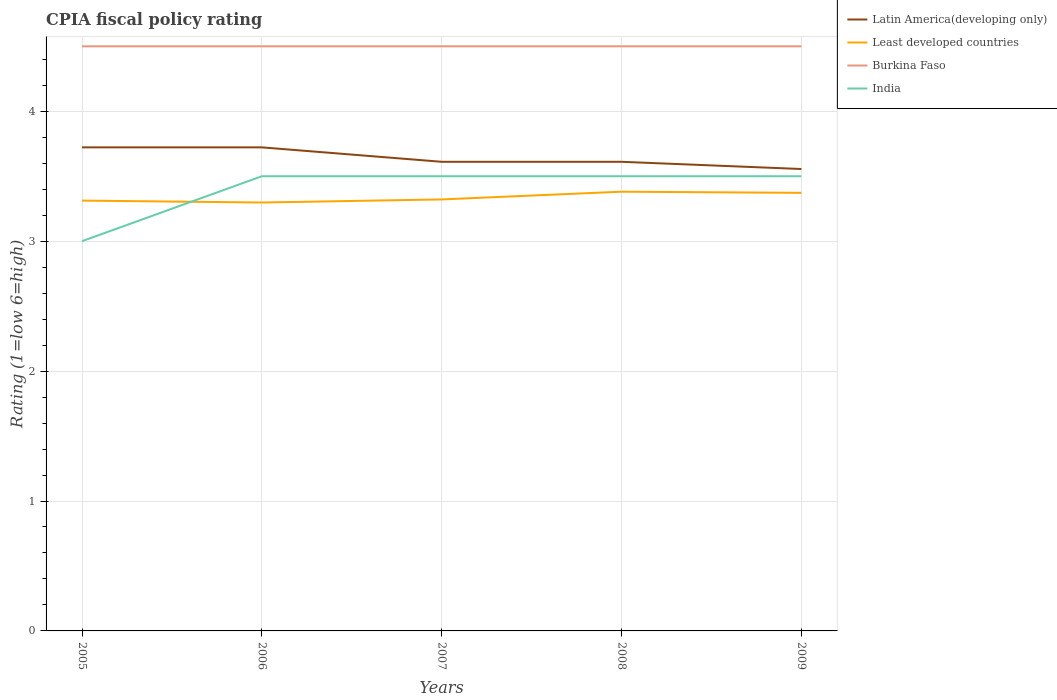Does the line corresponding to Burkina Faso intersect with the line corresponding to India?
Offer a very short reply. No. Across all years, what is the maximum CPIA rating in Latin America(developing only)?
Your answer should be very brief. 3.56. What is the total CPIA rating in India in the graph?
Provide a short and direct response. -0.5. What is the difference between the highest and the second highest CPIA rating in Burkina Faso?
Keep it short and to the point. 0. Is the CPIA rating in Latin America(developing only) strictly greater than the CPIA rating in Burkina Faso over the years?
Your response must be concise. Yes. What is the difference between two consecutive major ticks on the Y-axis?
Give a very brief answer. 1. Does the graph contain any zero values?
Keep it short and to the point. No. How many legend labels are there?
Your answer should be compact. 4. What is the title of the graph?
Offer a terse response. CPIA fiscal policy rating. Does "New Zealand" appear as one of the legend labels in the graph?
Provide a short and direct response. No. What is the label or title of the X-axis?
Give a very brief answer. Years. What is the Rating (1=low 6=high) in Latin America(developing only) in 2005?
Your answer should be compact. 3.72. What is the Rating (1=low 6=high) of Least developed countries in 2005?
Offer a very short reply. 3.31. What is the Rating (1=low 6=high) in India in 2005?
Provide a short and direct response. 3. What is the Rating (1=low 6=high) in Latin America(developing only) in 2006?
Provide a short and direct response. 3.72. What is the Rating (1=low 6=high) of Least developed countries in 2006?
Make the answer very short. 3.3. What is the Rating (1=low 6=high) in India in 2006?
Your answer should be very brief. 3.5. What is the Rating (1=low 6=high) in Latin America(developing only) in 2007?
Your answer should be very brief. 3.61. What is the Rating (1=low 6=high) in Least developed countries in 2007?
Make the answer very short. 3.32. What is the Rating (1=low 6=high) of Burkina Faso in 2007?
Provide a short and direct response. 4.5. What is the Rating (1=low 6=high) of India in 2007?
Make the answer very short. 3.5. What is the Rating (1=low 6=high) of Latin America(developing only) in 2008?
Offer a very short reply. 3.61. What is the Rating (1=low 6=high) of Least developed countries in 2008?
Make the answer very short. 3.38. What is the Rating (1=low 6=high) in Latin America(developing only) in 2009?
Keep it short and to the point. 3.56. What is the Rating (1=low 6=high) in Least developed countries in 2009?
Your answer should be compact. 3.37. What is the Rating (1=low 6=high) in India in 2009?
Your response must be concise. 3.5. Across all years, what is the maximum Rating (1=low 6=high) in Latin America(developing only)?
Your response must be concise. 3.72. Across all years, what is the maximum Rating (1=low 6=high) in Least developed countries?
Keep it short and to the point. 3.38. Across all years, what is the maximum Rating (1=low 6=high) in India?
Provide a short and direct response. 3.5. Across all years, what is the minimum Rating (1=low 6=high) in Latin America(developing only)?
Keep it short and to the point. 3.56. Across all years, what is the minimum Rating (1=low 6=high) in Least developed countries?
Give a very brief answer. 3.3. What is the total Rating (1=low 6=high) of Latin America(developing only) in the graph?
Offer a terse response. 18.22. What is the total Rating (1=low 6=high) of Least developed countries in the graph?
Provide a short and direct response. 16.68. What is the total Rating (1=low 6=high) of India in the graph?
Offer a terse response. 17. What is the difference between the Rating (1=low 6=high) of Least developed countries in 2005 and that in 2006?
Your answer should be compact. 0.01. What is the difference between the Rating (1=low 6=high) of Burkina Faso in 2005 and that in 2006?
Keep it short and to the point. 0. What is the difference between the Rating (1=low 6=high) in India in 2005 and that in 2006?
Offer a terse response. -0.5. What is the difference between the Rating (1=low 6=high) in Least developed countries in 2005 and that in 2007?
Make the answer very short. -0.01. What is the difference between the Rating (1=low 6=high) of Burkina Faso in 2005 and that in 2007?
Your answer should be compact. 0. What is the difference between the Rating (1=low 6=high) in India in 2005 and that in 2007?
Your answer should be compact. -0.5. What is the difference between the Rating (1=low 6=high) of Latin America(developing only) in 2005 and that in 2008?
Your answer should be very brief. 0.11. What is the difference between the Rating (1=low 6=high) in Least developed countries in 2005 and that in 2008?
Offer a terse response. -0.07. What is the difference between the Rating (1=low 6=high) of Burkina Faso in 2005 and that in 2008?
Your answer should be compact. 0. What is the difference between the Rating (1=low 6=high) in Latin America(developing only) in 2005 and that in 2009?
Your answer should be compact. 0.17. What is the difference between the Rating (1=low 6=high) of Least developed countries in 2005 and that in 2009?
Offer a very short reply. -0.06. What is the difference between the Rating (1=low 6=high) in Burkina Faso in 2005 and that in 2009?
Offer a very short reply. 0. What is the difference between the Rating (1=low 6=high) of India in 2005 and that in 2009?
Your answer should be compact. -0.5. What is the difference between the Rating (1=low 6=high) of Latin America(developing only) in 2006 and that in 2007?
Give a very brief answer. 0.11. What is the difference between the Rating (1=low 6=high) in Least developed countries in 2006 and that in 2007?
Your response must be concise. -0.02. What is the difference between the Rating (1=low 6=high) of India in 2006 and that in 2007?
Offer a terse response. 0. What is the difference between the Rating (1=low 6=high) in Latin America(developing only) in 2006 and that in 2008?
Keep it short and to the point. 0.11. What is the difference between the Rating (1=low 6=high) of Least developed countries in 2006 and that in 2008?
Ensure brevity in your answer.  -0.08. What is the difference between the Rating (1=low 6=high) of Latin America(developing only) in 2006 and that in 2009?
Your answer should be compact. 0.17. What is the difference between the Rating (1=low 6=high) of Least developed countries in 2006 and that in 2009?
Give a very brief answer. -0.07. What is the difference between the Rating (1=low 6=high) of Burkina Faso in 2006 and that in 2009?
Keep it short and to the point. 0. What is the difference between the Rating (1=low 6=high) in India in 2006 and that in 2009?
Provide a short and direct response. 0. What is the difference between the Rating (1=low 6=high) of Latin America(developing only) in 2007 and that in 2008?
Ensure brevity in your answer.  0. What is the difference between the Rating (1=low 6=high) in Least developed countries in 2007 and that in 2008?
Your response must be concise. -0.06. What is the difference between the Rating (1=low 6=high) in India in 2007 and that in 2008?
Offer a very short reply. 0. What is the difference between the Rating (1=low 6=high) in Latin America(developing only) in 2007 and that in 2009?
Give a very brief answer. 0.06. What is the difference between the Rating (1=low 6=high) in Least developed countries in 2007 and that in 2009?
Your answer should be compact. -0.05. What is the difference between the Rating (1=low 6=high) in Burkina Faso in 2007 and that in 2009?
Keep it short and to the point. 0. What is the difference between the Rating (1=low 6=high) in India in 2007 and that in 2009?
Your answer should be compact. 0. What is the difference between the Rating (1=low 6=high) in Latin America(developing only) in 2008 and that in 2009?
Provide a short and direct response. 0.06. What is the difference between the Rating (1=low 6=high) in Least developed countries in 2008 and that in 2009?
Give a very brief answer. 0.01. What is the difference between the Rating (1=low 6=high) of Burkina Faso in 2008 and that in 2009?
Offer a terse response. 0. What is the difference between the Rating (1=low 6=high) of Latin America(developing only) in 2005 and the Rating (1=low 6=high) of Least developed countries in 2006?
Your answer should be very brief. 0.42. What is the difference between the Rating (1=low 6=high) in Latin America(developing only) in 2005 and the Rating (1=low 6=high) in Burkina Faso in 2006?
Your answer should be compact. -0.78. What is the difference between the Rating (1=low 6=high) in Latin America(developing only) in 2005 and the Rating (1=low 6=high) in India in 2006?
Your answer should be very brief. 0.22. What is the difference between the Rating (1=low 6=high) of Least developed countries in 2005 and the Rating (1=low 6=high) of Burkina Faso in 2006?
Give a very brief answer. -1.19. What is the difference between the Rating (1=low 6=high) in Least developed countries in 2005 and the Rating (1=low 6=high) in India in 2006?
Make the answer very short. -0.19. What is the difference between the Rating (1=low 6=high) in Latin America(developing only) in 2005 and the Rating (1=low 6=high) in Least developed countries in 2007?
Keep it short and to the point. 0.4. What is the difference between the Rating (1=low 6=high) in Latin America(developing only) in 2005 and the Rating (1=low 6=high) in Burkina Faso in 2007?
Provide a short and direct response. -0.78. What is the difference between the Rating (1=low 6=high) of Latin America(developing only) in 2005 and the Rating (1=low 6=high) of India in 2007?
Provide a succinct answer. 0.22. What is the difference between the Rating (1=low 6=high) in Least developed countries in 2005 and the Rating (1=low 6=high) in Burkina Faso in 2007?
Make the answer very short. -1.19. What is the difference between the Rating (1=low 6=high) of Least developed countries in 2005 and the Rating (1=low 6=high) of India in 2007?
Your answer should be compact. -0.19. What is the difference between the Rating (1=low 6=high) in Latin America(developing only) in 2005 and the Rating (1=low 6=high) in Least developed countries in 2008?
Offer a terse response. 0.34. What is the difference between the Rating (1=low 6=high) of Latin America(developing only) in 2005 and the Rating (1=low 6=high) of Burkina Faso in 2008?
Offer a terse response. -0.78. What is the difference between the Rating (1=low 6=high) in Latin America(developing only) in 2005 and the Rating (1=low 6=high) in India in 2008?
Your answer should be compact. 0.22. What is the difference between the Rating (1=low 6=high) of Least developed countries in 2005 and the Rating (1=low 6=high) of Burkina Faso in 2008?
Give a very brief answer. -1.19. What is the difference between the Rating (1=low 6=high) of Least developed countries in 2005 and the Rating (1=low 6=high) of India in 2008?
Provide a succinct answer. -0.19. What is the difference between the Rating (1=low 6=high) of Burkina Faso in 2005 and the Rating (1=low 6=high) of India in 2008?
Your answer should be very brief. 1. What is the difference between the Rating (1=low 6=high) of Latin America(developing only) in 2005 and the Rating (1=low 6=high) of Least developed countries in 2009?
Make the answer very short. 0.35. What is the difference between the Rating (1=low 6=high) of Latin America(developing only) in 2005 and the Rating (1=low 6=high) of Burkina Faso in 2009?
Keep it short and to the point. -0.78. What is the difference between the Rating (1=low 6=high) of Latin America(developing only) in 2005 and the Rating (1=low 6=high) of India in 2009?
Provide a succinct answer. 0.22. What is the difference between the Rating (1=low 6=high) in Least developed countries in 2005 and the Rating (1=low 6=high) in Burkina Faso in 2009?
Offer a terse response. -1.19. What is the difference between the Rating (1=low 6=high) of Least developed countries in 2005 and the Rating (1=low 6=high) of India in 2009?
Offer a terse response. -0.19. What is the difference between the Rating (1=low 6=high) in Latin America(developing only) in 2006 and the Rating (1=low 6=high) in Least developed countries in 2007?
Provide a short and direct response. 0.4. What is the difference between the Rating (1=low 6=high) of Latin America(developing only) in 2006 and the Rating (1=low 6=high) of Burkina Faso in 2007?
Offer a terse response. -0.78. What is the difference between the Rating (1=low 6=high) in Latin America(developing only) in 2006 and the Rating (1=low 6=high) in India in 2007?
Ensure brevity in your answer.  0.22. What is the difference between the Rating (1=low 6=high) of Least developed countries in 2006 and the Rating (1=low 6=high) of Burkina Faso in 2007?
Your answer should be compact. -1.2. What is the difference between the Rating (1=low 6=high) of Least developed countries in 2006 and the Rating (1=low 6=high) of India in 2007?
Make the answer very short. -0.2. What is the difference between the Rating (1=low 6=high) in Burkina Faso in 2006 and the Rating (1=low 6=high) in India in 2007?
Give a very brief answer. 1. What is the difference between the Rating (1=low 6=high) in Latin America(developing only) in 2006 and the Rating (1=low 6=high) in Least developed countries in 2008?
Your answer should be compact. 0.34. What is the difference between the Rating (1=low 6=high) in Latin America(developing only) in 2006 and the Rating (1=low 6=high) in Burkina Faso in 2008?
Provide a succinct answer. -0.78. What is the difference between the Rating (1=low 6=high) of Latin America(developing only) in 2006 and the Rating (1=low 6=high) of India in 2008?
Make the answer very short. 0.22. What is the difference between the Rating (1=low 6=high) in Least developed countries in 2006 and the Rating (1=low 6=high) in Burkina Faso in 2008?
Provide a succinct answer. -1.2. What is the difference between the Rating (1=low 6=high) of Least developed countries in 2006 and the Rating (1=low 6=high) of India in 2008?
Offer a terse response. -0.2. What is the difference between the Rating (1=low 6=high) of Latin America(developing only) in 2006 and the Rating (1=low 6=high) of Least developed countries in 2009?
Your response must be concise. 0.35. What is the difference between the Rating (1=low 6=high) of Latin America(developing only) in 2006 and the Rating (1=low 6=high) of Burkina Faso in 2009?
Offer a very short reply. -0.78. What is the difference between the Rating (1=low 6=high) in Latin America(developing only) in 2006 and the Rating (1=low 6=high) in India in 2009?
Your answer should be compact. 0.22. What is the difference between the Rating (1=low 6=high) of Least developed countries in 2006 and the Rating (1=low 6=high) of Burkina Faso in 2009?
Offer a very short reply. -1.2. What is the difference between the Rating (1=low 6=high) of Least developed countries in 2006 and the Rating (1=low 6=high) of India in 2009?
Provide a succinct answer. -0.2. What is the difference between the Rating (1=low 6=high) of Latin America(developing only) in 2007 and the Rating (1=low 6=high) of Least developed countries in 2008?
Keep it short and to the point. 0.23. What is the difference between the Rating (1=low 6=high) of Latin America(developing only) in 2007 and the Rating (1=low 6=high) of Burkina Faso in 2008?
Your answer should be compact. -0.89. What is the difference between the Rating (1=low 6=high) in Latin America(developing only) in 2007 and the Rating (1=low 6=high) in India in 2008?
Your answer should be compact. 0.11. What is the difference between the Rating (1=low 6=high) of Least developed countries in 2007 and the Rating (1=low 6=high) of Burkina Faso in 2008?
Give a very brief answer. -1.18. What is the difference between the Rating (1=low 6=high) in Least developed countries in 2007 and the Rating (1=low 6=high) in India in 2008?
Ensure brevity in your answer.  -0.18. What is the difference between the Rating (1=low 6=high) of Latin America(developing only) in 2007 and the Rating (1=low 6=high) of Least developed countries in 2009?
Provide a succinct answer. 0.24. What is the difference between the Rating (1=low 6=high) of Latin America(developing only) in 2007 and the Rating (1=low 6=high) of Burkina Faso in 2009?
Your response must be concise. -0.89. What is the difference between the Rating (1=low 6=high) in Latin America(developing only) in 2007 and the Rating (1=low 6=high) in India in 2009?
Give a very brief answer. 0.11. What is the difference between the Rating (1=low 6=high) of Least developed countries in 2007 and the Rating (1=low 6=high) of Burkina Faso in 2009?
Ensure brevity in your answer.  -1.18. What is the difference between the Rating (1=low 6=high) in Least developed countries in 2007 and the Rating (1=low 6=high) in India in 2009?
Offer a very short reply. -0.18. What is the difference between the Rating (1=low 6=high) of Latin America(developing only) in 2008 and the Rating (1=low 6=high) of Least developed countries in 2009?
Give a very brief answer. 0.24. What is the difference between the Rating (1=low 6=high) in Latin America(developing only) in 2008 and the Rating (1=low 6=high) in Burkina Faso in 2009?
Your response must be concise. -0.89. What is the difference between the Rating (1=low 6=high) of Least developed countries in 2008 and the Rating (1=low 6=high) of Burkina Faso in 2009?
Make the answer very short. -1.12. What is the difference between the Rating (1=low 6=high) of Least developed countries in 2008 and the Rating (1=low 6=high) of India in 2009?
Keep it short and to the point. -0.12. What is the difference between the Rating (1=low 6=high) in Burkina Faso in 2008 and the Rating (1=low 6=high) in India in 2009?
Make the answer very short. 1. What is the average Rating (1=low 6=high) of Latin America(developing only) per year?
Offer a terse response. 3.64. What is the average Rating (1=low 6=high) of Least developed countries per year?
Your answer should be very brief. 3.34. What is the average Rating (1=low 6=high) of India per year?
Offer a terse response. 3.4. In the year 2005, what is the difference between the Rating (1=low 6=high) of Latin America(developing only) and Rating (1=low 6=high) of Least developed countries?
Your response must be concise. 0.41. In the year 2005, what is the difference between the Rating (1=low 6=high) of Latin America(developing only) and Rating (1=low 6=high) of Burkina Faso?
Provide a succinct answer. -0.78. In the year 2005, what is the difference between the Rating (1=low 6=high) of Latin America(developing only) and Rating (1=low 6=high) of India?
Provide a succinct answer. 0.72. In the year 2005, what is the difference between the Rating (1=low 6=high) in Least developed countries and Rating (1=low 6=high) in Burkina Faso?
Your response must be concise. -1.19. In the year 2005, what is the difference between the Rating (1=low 6=high) in Least developed countries and Rating (1=low 6=high) in India?
Your response must be concise. 0.31. In the year 2005, what is the difference between the Rating (1=low 6=high) in Burkina Faso and Rating (1=low 6=high) in India?
Ensure brevity in your answer.  1.5. In the year 2006, what is the difference between the Rating (1=low 6=high) of Latin America(developing only) and Rating (1=low 6=high) of Least developed countries?
Keep it short and to the point. 0.42. In the year 2006, what is the difference between the Rating (1=low 6=high) in Latin America(developing only) and Rating (1=low 6=high) in Burkina Faso?
Provide a succinct answer. -0.78. In the year 2006, what is the difference between the Rating (1=low 6=high) in Latin America(developing only) and Rating (1=low 6=high) in India?
Provide a succinct answer. 0.22. In the year 2006, what is the difference between the Rating (1=low 6=high) in Least developed countries and Rating (1=low 6=high) in Burkina Faso?
Provide a short and direct response. -1.2. In the year 2006, what is the difference between the Rating (1=low 6=high) of Least developed countries and Rating (1=low 6=high) of India?
Ensure brevity in your answer.  -0.2. In the year 2006, what is the difference between the Rating (1=low 6=high) of Burkina Faso and Rating (1=low 6=high) of India?
Keep it short and to the point. 1. In the year 2007, what is the difference between the Rating (1=low 6=high) of Latin America(developing only) and Rating (1=low 6=high) of Least developed countries?
Make the answer very short. 0.29. In the year 2007, what is the difference between the Rating (1=low 6=high) of Latin America(developing only) and Rating (1=low 6=high) of Burkina Faso?
Your answer should be compact. -0.89. In the year 2007, what is the difference between the Rating (1=low 6=high) of Least developed countries and Rating (1=low 6=high) of Burkina Faso?
Your response must be concise. -1.18. In the year 2007, what is the difference between the Rating (1=low 6=high) in Least developed countries and Rating (1=low 6=high) in India?
Provide a succinct answer. -0.18. In the year 2007, what is the difference between the Rating (1=low 6=high) of Burkina Faso and Rating (1=low 6=high) of India?
Make the answer very short. 1. In the year 2008, what is the difference between the Rating (1=low 6=high) in Latin America(developing only) and Rating (1=low 6=high) in Least developed countries?
Provide a succinct answer. 0.23. In the year 2008, what is the difference between the Rating (1=low 6=high) in Latin America(developing only) and Rating (1=low 6=high) in Burkina Faso?
Your answer should be compact. -0.89. In the year 2008, what is the difference between the Rating (1=low 6=high) of Least developed countries and Rating (1=low 6=high) of Burkina Faso?
Give a very brief answer. -1.12. In the year 2008, what is the difference between the Rating (1=low 6=high) of Least developed countries and Rating (1=low 6=high) of India?
Make the answer very short. -0.12. In the year 2009, what is the difference between the Rating (1=low 6=high) of Latin America(developing only) and Rating (1=low 6=high) of Least developed countries?
Provide a succinct answer. 0.18. In the year 2009, what is the difference between the Rating (1=low 6=high) in Latin America(developing only) and Rating (1=low 6=high) in Burkina Faso?
Provide a succinct answer. -0.94. In the year 2009, what is the difference between the Rating (1=low 6=high) in Latin America(developing only) and Rating (1=low 6=high) in India?
Your answer should be compact. 0.06. In the year 2009, what is the difference between the Rating (1=low 6=high) in Least developed countries and Rating (1=low 6=high) in Burkina Faso?
Your response must be concise. -1.13. In the year 2009, what is the difference between the Rating (1=low 6=high) of Least developed countries and Rating (1=low 6=high) of India?
Keep it short and to the point. -0.13. In the year 2009, what is the difference between the Rating (1=low 6=high) of Burkina Faso and Rating (1=low 6=high) of India?
Offer a terse response. 1. What is the ratio of the Rating (1=low 6=high) of Least developed countries in 2005 to that in 2006?
Give a very brief answer. 1. What is the ratio of the Rating (1=low 6=high) in Latin America(developing only) in 2005 to that in 2007?
Provide a succinct answer. 1.03. What is the ratio of the Rating (1=low 6=high) in Least developed countries in 2005 to that in 2007?
Offer a terse response. 1. What is the ratio of the Rating (1=low 6=high) in Latin America(developing only) in 2005 to that in 2008?
Your response must be concise. 1.03. What is the ratio of the Rating (1=low 6=high) of Least developed countries in 2005 to that in 2008?
Your response must be concise. 0.98. What is the ratio of the Rating (1=low 6=high) of Burkina Faso in 2005 to that in 2008?
Your response must be concise. 1. What is the ratio of the Rating (1=low 6=high) in India in 2005 to that in 2008?
Your answer should be compact. 0.86. What is the ratio of the Rating (1=low 6=high) in Latin America(developing only) in 2005 to that in 2009?
Offer a very short reply. 1.05. What is the ratio of the Rating (1=low 6=high) in Least developed countries in 2005 to that in 2009?
Offer a very short reply. 0.98. What is the ratio of the Rating (1=low 6=high) of Burkina Faso in 2005 to that in 2009?
Your answer should be compact. 1. What is the ratio of the Rating (1=low 6=high) of India in 2005 to that in 2009?
Give a very brief answer. 0.86. What is the ratio of the Rating (1=low 6=high) in Latin America(developing only) in 2006 to that in 2007?
Provide a short and direct response. 1.03. What is the ratio of the Rating (1=low 6=high) of Burkina Faso in 2006 to that in 2007?
Your answer should be compact. 1. What is the ratio of the Rating (1=low 6=high) in India in 2006 to that in 2007?
Make the answer very short. 1. What is the ratio of the Rating (1=low 6=high) in Latin America(developing only) in 2006 to that in 2008?
Your answer should be compact. 1.03. What is the ratio of the Rating (1=low 6=high) in Least developed countries in 2006 to that in 2008?
Your answer should be compact. 0.98. What is the ratio of the Rating (1=low 6=high) in Latin America(developing only) in 2006 to that in 2009?
Your answer should be compact. 1.05. What is the ratio of the Rating (1=low 6=high) in Least developed countries in 2006 to that in 2009?
Provide a short and direct response. 0.98. What is the ratio of the Rating (1=low 6=high) in Burkina Faso in 2006 to that in 2009?
Your answer should be compact. 1. What is the ratio of the Rating (1=low 6=high) of India in 2006 to that in 2009?
Your response must be concise. 1. What is the ratio of the Rating (1=low 6=high) in Latin America(developing only) in 2007 to that in 2008?
Provide a succinct answer. 1. What is the ratio of the Rating (1=low 6=high) of Least developed countries in 2007 to that in 2008?
Offer a very short reply. 0.98. What is the ratio of the Rating (1=low 6=high) in Latin America(developing only) in 2007 to that in 2009?
Make the answer very short. 1.02. What is the ratio of the Rating (1=low 6=high) in Least developed countries in 2007 to that in 2009?
Your response must be concise. 0.98. What is the ratio of the Rating (1=low 6=high) in Latin America(developing only) in 2008 to that in 2009?
Give a very brief answer. 1.02. What is the ratio of the Rating (1=low 6=high) in Burkina Faso in 2008 to that in 2009?
Provide a succinct answer. 1. What is the difference between the highest and the second highest Rating (1=low 6=high) in Least developed countries?
Your response must be concise. 0.01. What is the difference between the highest and the second highest Rating (1=low 6=high) of Burkina Faso?
Offer a terse response. 0. What is the difference between the highest and the lowest Rating (1=low 6=high) of Least developed countries?
Provide a short and direct response. 0.08. What is the difference between the highest and the lowest Rating (1=low 6=high) of Burkina Faso?
Make the answer very short. 0. 